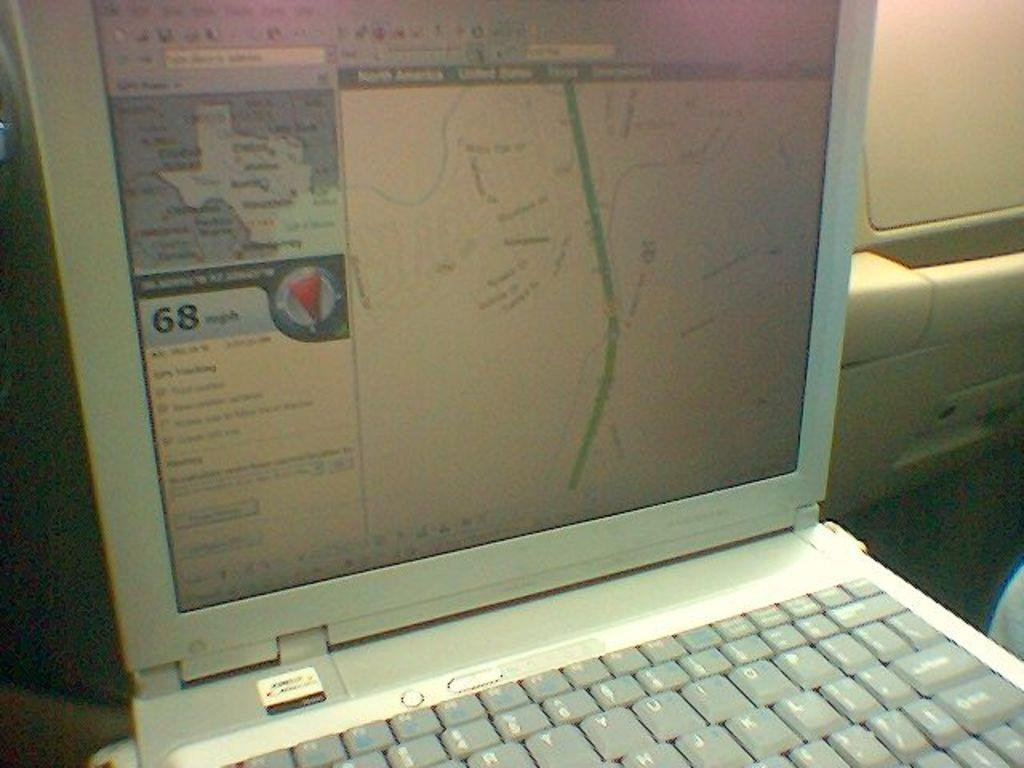What electronic device is visible in the image? There is a laptop in the image. What color is the background of the image? The background of the image is cream-colored. What type of chalk is being used to write on the laptop screen in the image? There is no chalk or writing on the laptop screen in the image. What brand of soda is visible on the table next to the laptop in the image? There is no soda or table present in the image; only the laptop and the cream-colored background are visible. 